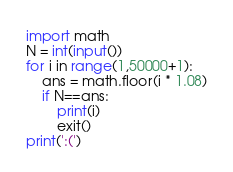<code> <loc_0><loc_0><loc_500><loc_500><_Python_>import math
N = int(input())
for i in range(1,50000+1):
    ans = math.floor(i * 1.08)
    if N==ans:
        print(i)
        exit()
print(':(')</code> 